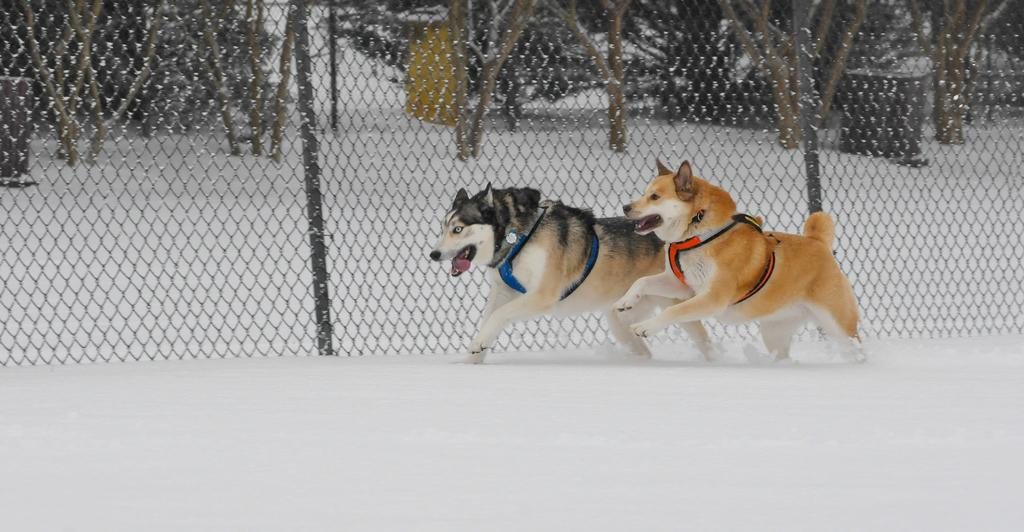What type of animals are in the image? There are a husky and a dog in the image. What are the animals doing in the image? The animals are running on the snow. What can be seen in the background of the image? There is mesh, poles, trees, and other objects visible in the background of the image. What type of record can be seen spinning on a turntable in the image? There is no record or turntable present in the image; it features a husky and a dog running on the snow with a background of mesh, poles, trees, and other objects. 